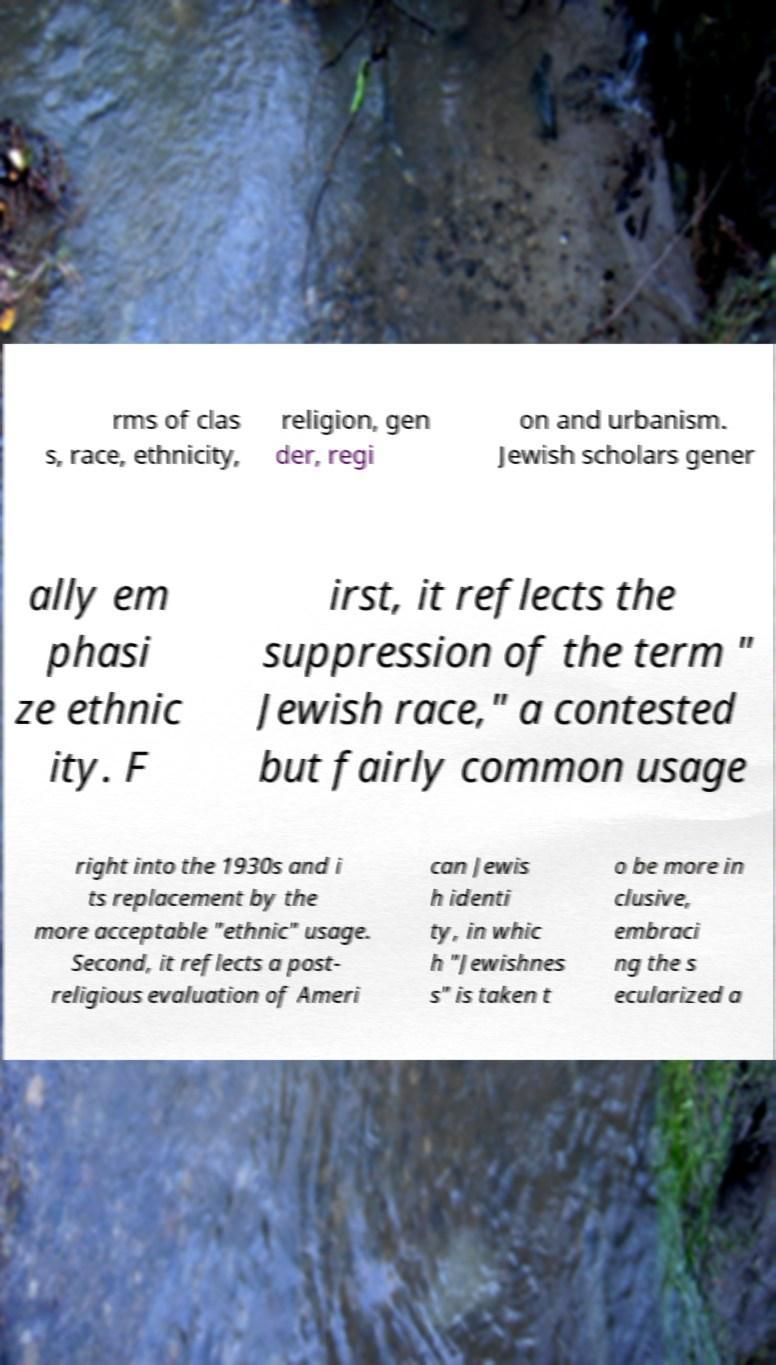I need the written content from this picture converted into text. Can you do that? rms of clas s, race, ethnicity, religion, gen der, regi on and urbanism. Jewish scholars gener ally em phasi ze ethnic ity. F irst, it reflects the suppression of the term " Jewish race," a contested but fairly common usage right into the 1930s and i ts replacement by the more acceptable "ethnic" usage. Second, it reflects a post- religious evaluation of Ameri can Jewis h identi ty, in whic h "Jewishnes s" is taken t o be more in clusive, embraci ng the s ecularized a 